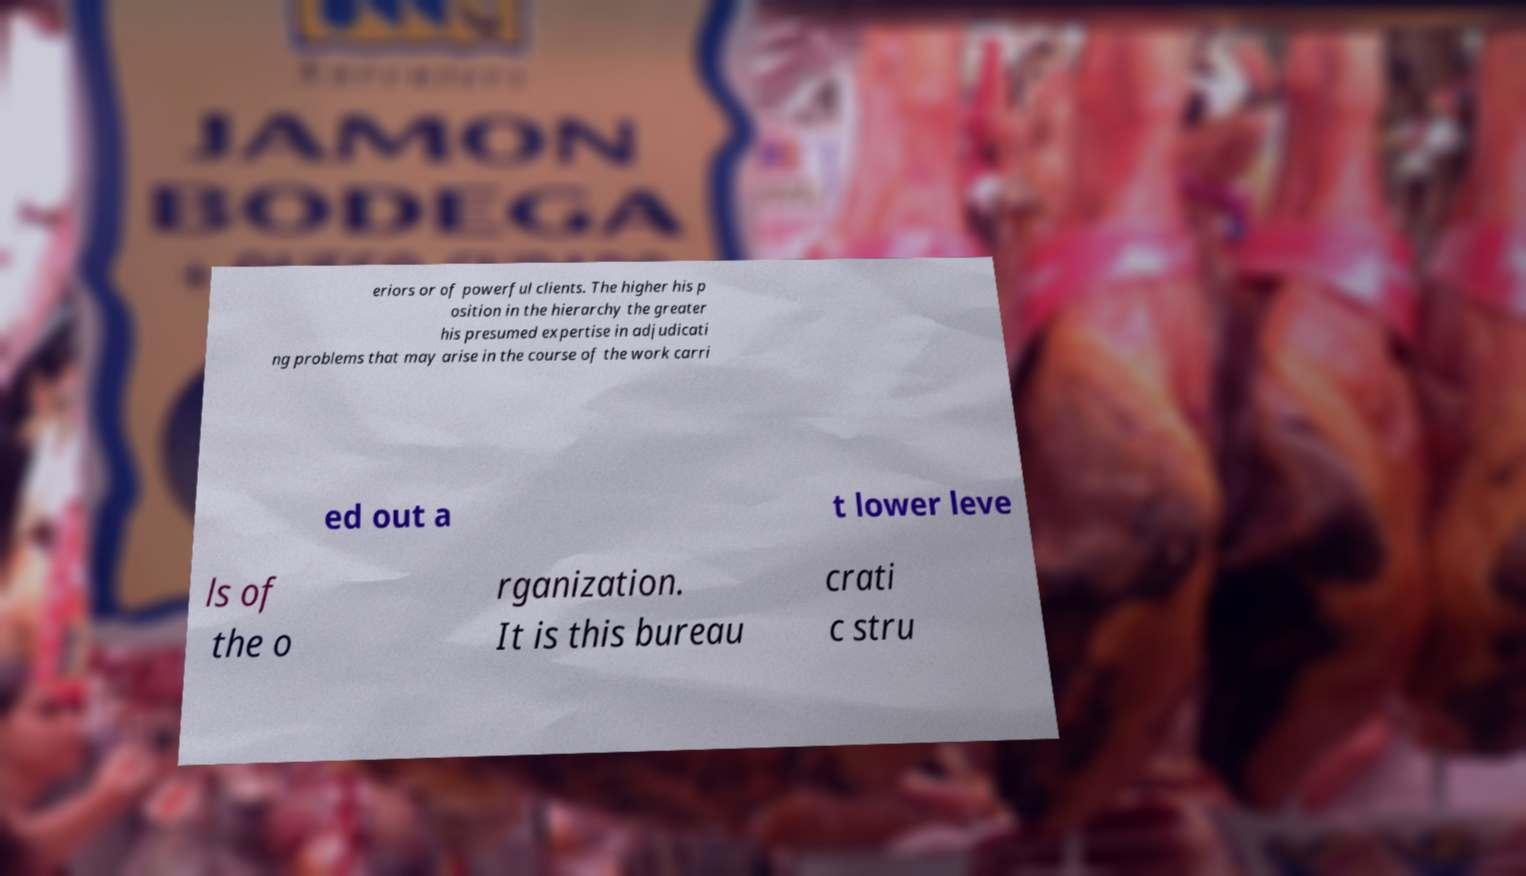Could you assist in decoding the text presented in this image and type it out clearly? eriors or of powerful clients. The higher his p osition in the hierarchy the greater his presumed expertise in adjudicati ng problems that may arise in the course of the work carri ed out a t lower leve ls of the o rganization. It is this bureau crati c stru 